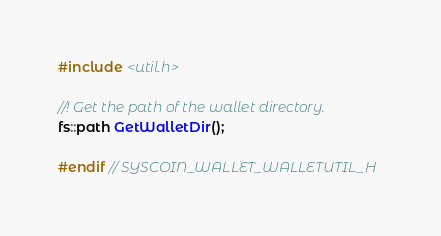<code> <loc_0><loc_0><loc_500><loc_500><_C_>#include <util.h>

//! Get the path of the wallet directory.
fs::path GetWalletDir();

#endif // SYSCOIN_WALLET_WALLETUTIL_H
</code> 